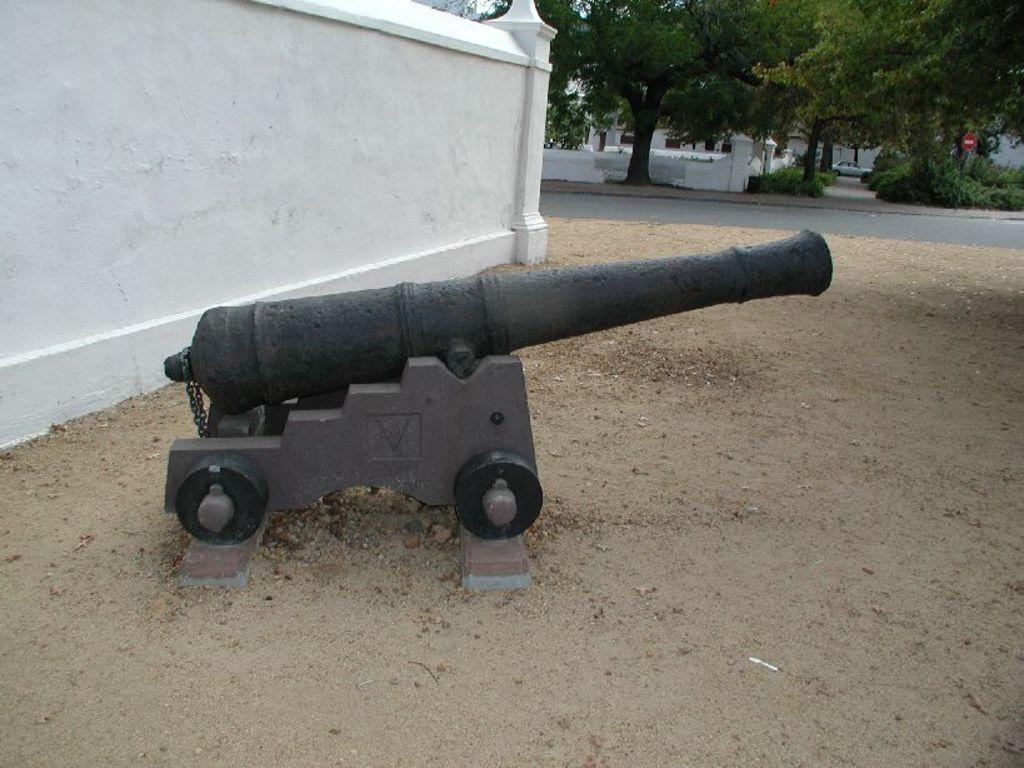Could you give a brief overview of what you see in this image? There is an old machine gun kept in front of a wall and in the background there are a lot of trees and a caution board behind the road. 